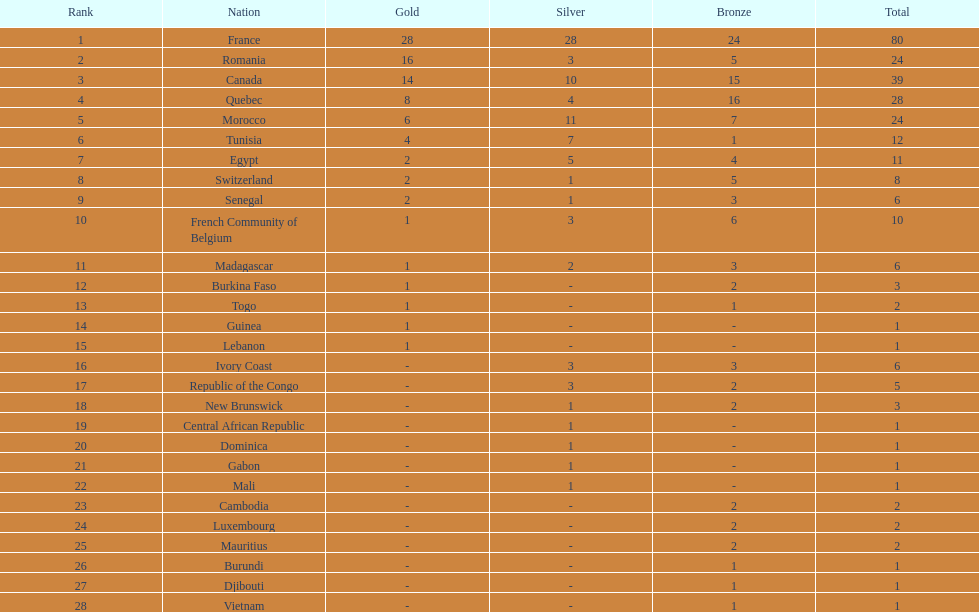What was the complete medal sum for switzerland? 8. 